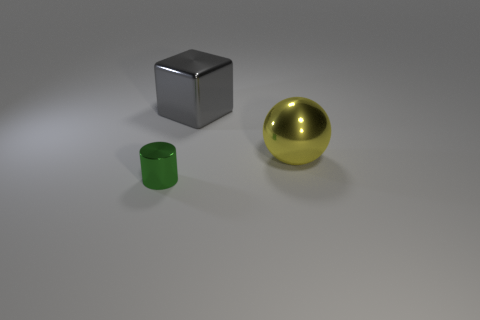Do the green thing and the large object behind the yellow ball have the same shape? No, they do not have the same shape. The green object is cylindrical, while the large object behind the yellow ball is a cube. 